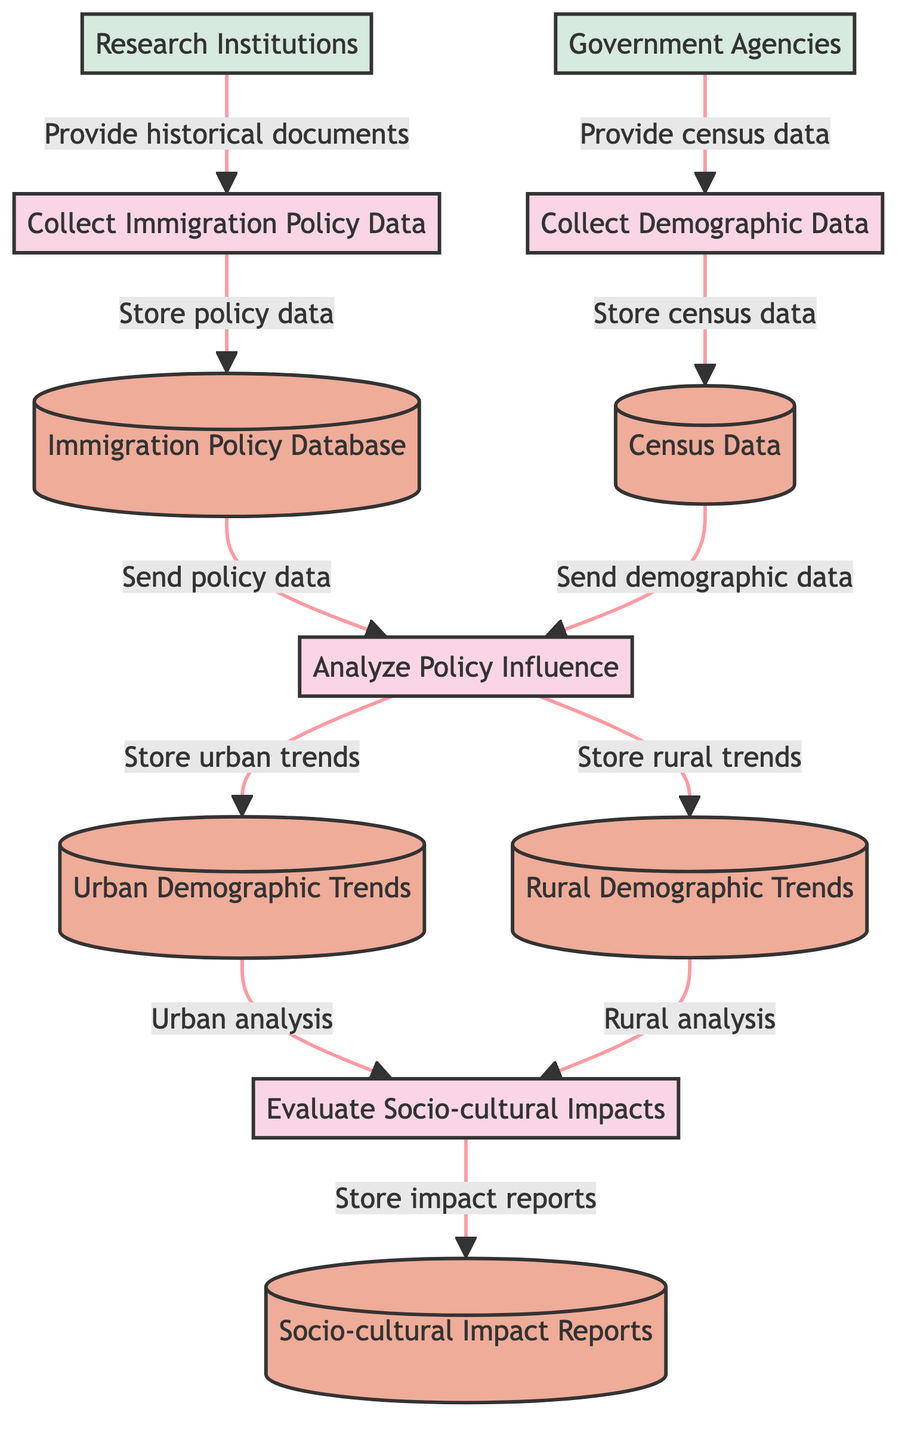What is the first process in the diagram? The first process listed in the diagram is "Collect Immigration Policy Data", which is indicated by the label in the diagram.
Answer: Collect Immigration Policy Data How many data stores are present in the diagram? The diagram contains five data stores as identified within the labeled nodes presented in the data structure.
Answer: 5 Which external entity provides census data? The external entity responsible for providing census data is "Government Agencies," clearly marked in the diagram's relationships.
Answer: Government Agencies What is stored in the "Urban Demographic Trends" data store? The "Urban Demographic Trends" data store contains the results of the analysis of demographic trends in urban areas, as indicated by its connection to the "Analyze Policy Influence" process.
Answer: Analysis results of urban demographic trends What flows from "Collect Demographic Data" to "Census Data"? The flow from "Collect Demographic Data" to "Census Data" indicates that census data collected is stored in the "Census Data" data store, reflecting a direct action from the process to the datastore.
Answer: Store collected census data Which process receives input from both "Immigration Policy Database" and "Census Data"? The process that receives input from both the "Immigration Policy Database" and "Census Data" is "Analyze Policy Influence", making it a key stage in the diagram for combining these data sources.
Answer: Analyze Policy Influence What is the output of the "Evaluate Socio-cultural Impacts" process? The output of the "Evaluate Socio-cultural Impacts" process is stored in the "Socio-cultural Impact Reports," showing the end result of the analysis carried out on urban and rural demographic trends.
Answer: Socio-cultural Impact Reports How many processes analyze the influence of immigration policies? The diagram depicts two processes that analyze the influence of immigration policies directly: "Analyze Policy Influence" and "Evaluate Socio-cultural Impacts," which form a sequential relationship.
Answer: 2 What type of reports are produced at the end of the diagram's flow? The type of reports produced at the end of the flow is "Socio-cultural Impact Reports", which summarizes the socio-cultural impacts identified through the analysis of demographic changes.
Answer: Socio-cultural Impact Reports 